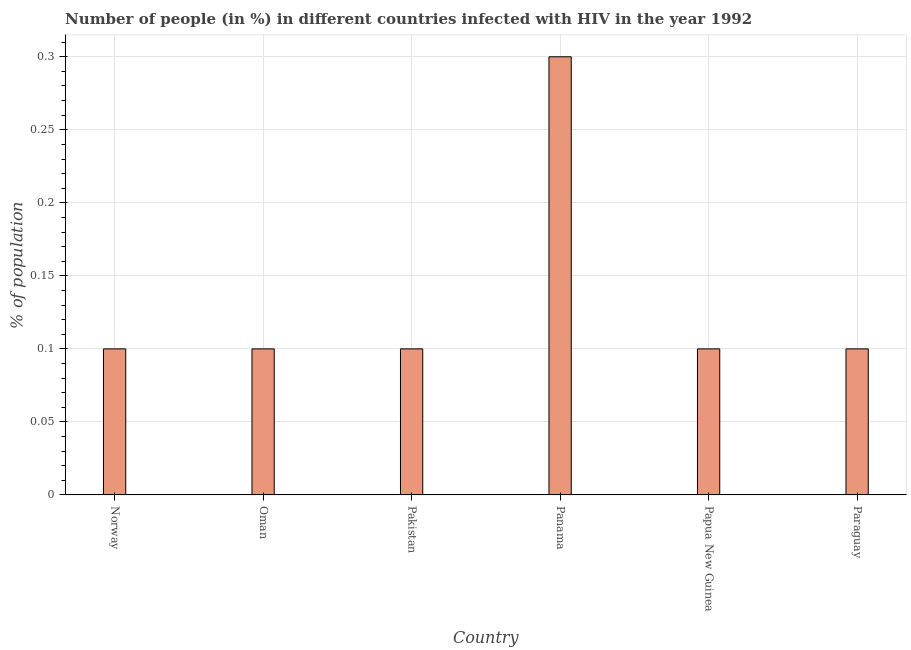Does the graph contain any zero values?
Provide a succinct answer. No. Does the graph contain grids?
Your answer should be compact. Yes. What is the title of the graph?
Your answer should be compact. Number of people (in %) in different countries infected with HIV in the year 1992. What is the label or title of the Y-axis?
Your answer should be very brief. % of population. What is the number of people infected with hiv in Panama?
Provide a succinct answer. 0.3. Across all countries, what is the maximum number of people infected with hiv?
Keep it short and to the point. 0.3. In which country was the number of people infected with hiv maximum?
Offer a terse response. Panama. What is the sum of the number of people infected with hiv?
Ensure brevity in your answer.  0.8. What is the average number of people infected with hiv per country?
Ensure brevity in your answer.  0.13. In how many countries, is the number of people infected with hiv greater than 0.2 %?
Offer a terse response. 1. What is the ratio of the number of people infected with hiv in Oman to that in Panama?
Make the answer very short. 0.33. Is the difference between the number of people infected with hiv in Panama and Papua New Guinea greater than the difference between any two countries?
Make the answer very short. Yes. Is the sum of the number of people infected with hiv in Pakistan and Panama greater than the maximum number of people infected with hiv across all countries?
Make the answer very short. Yes. What is the difference between the highest and the lowest number of people infected with hiv?
Give a very brief answer. 0.2. What is the difference between two consecutive major ticks on the Y-axis?
Ensure brevity in your answer.  0.05. What is the % of population in Norway?
Ensure brevity in your answer.  0.1. What is the % of population of Paraguay?
Ensure brevity in your answer.  0.1. What is the difference between the % of population in Norway and Panama?
Your answer should be very brief. -0.2. What is the difference between the % of population in Oman and Panama?
Your answer should be compact. -0.2. What is the difference between the % of population in Oman and Papua New Guinea?
Ensure brevity in your answer.  0. What is the difference between the % of population in Oman and Paraguay?
Make the answer very short. 0. What is the difference between the % of population in Pakistan and Paraguay?
Your answer should be compact. 0. What is the difference between the % of population in Panama and Papua New Guinea?
Provide a short and direct response. 0.2. What is the difference between the % of population in Panama and Paraguay?
Give a very brief answer. 0.2. What is the difference between the % of population in Papua New Guinea and Paraguay?
Provide a short and direct response. 0. What is the ratio of the % of population in Norway to that in Oman?
Your response must be concise. 1. What is the ratio of the % of population in Norway to that in Panama?
Your answer should be very brief. 0.33. What is the ratio of the % of population in Norway to that in Papua New Guinea?
Provide a succinct answer. 1. What is the ratio of the % of population in Oman to that in Panama?
Your response must be concise. 0.33. What is the ratio of the % of population in Oman to that in Paraguay?
Your response must be concise. 1. What is the ratio of the % of population in Pakistan to that in Panama?
Provide a succinct answer. 0.33. What is the ratio of the % of population in Pakistan to that in Papua New Guinea?
Keep it short and to the point. 1. What is the ratio of the % of population in Pakistan to that in Paraguay?
Provide a succinct answer. 1. What is the ratio of the % of population in Panama to that in Papua New Guinea?
Your answer should be compact. 3. What is the ratio of the % of population in Panama to that in Paraguay?
Your response must be concise. 3. 